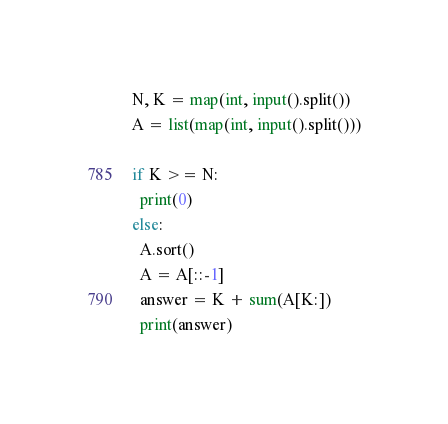Convert code to text. <code><loc_0><loc_0><loc_500><loc_500><_Python_>N, K = map(int, input().split())
A = list(map(int, input().split()))

if K >= N:
  print(0)
else:
  A.sort()
  A = A[::-1]
  answer = K + sum(A[K:])
  print(answer)</code> 